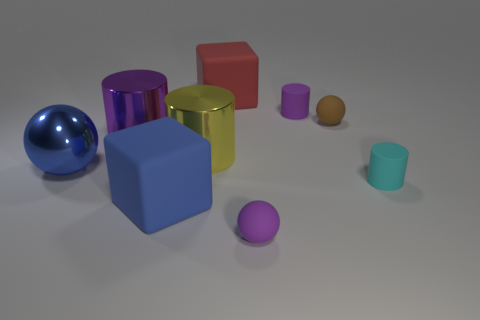There is a yellow metallic cylinder; are there any rubber things in front of it?
Ensure brevity in your answer.  Yes. How many rubber objects are either large blocks or small yellow things?
Your response must be concise. 2. There is a red rubber thing; what number of large blue shiny objects are in front of it?
Your response must be concise. 1. Are there any blue rubber objects of the same size as the yellow metallic thing?
Offer a very short reply. Yes. Are there any big objects that have the same color as the big metallic ball?
Your response must be concise. Yes. What number of rubber objects are the same color as the large metallic sphere?
Provide a succinct answer. 1. There is a metallic ball; does it have the same color as the big rubber cube in front of the big red cube?
Provide a succinct answer. Yes. How many things are large metal things or brown matte balls left of the cyan matte thing?
Make the answer very short. 4. There is a purple rubber object that is left of the tiny purple matte thing behind the yellow cylinder; how big is it?
Offer a terse response. Small. Are there the same number of big red things in front of the red matte object and yellow cylinders to the right of the yellow metal object?
Ensure brevity in your answer.  Yes. 